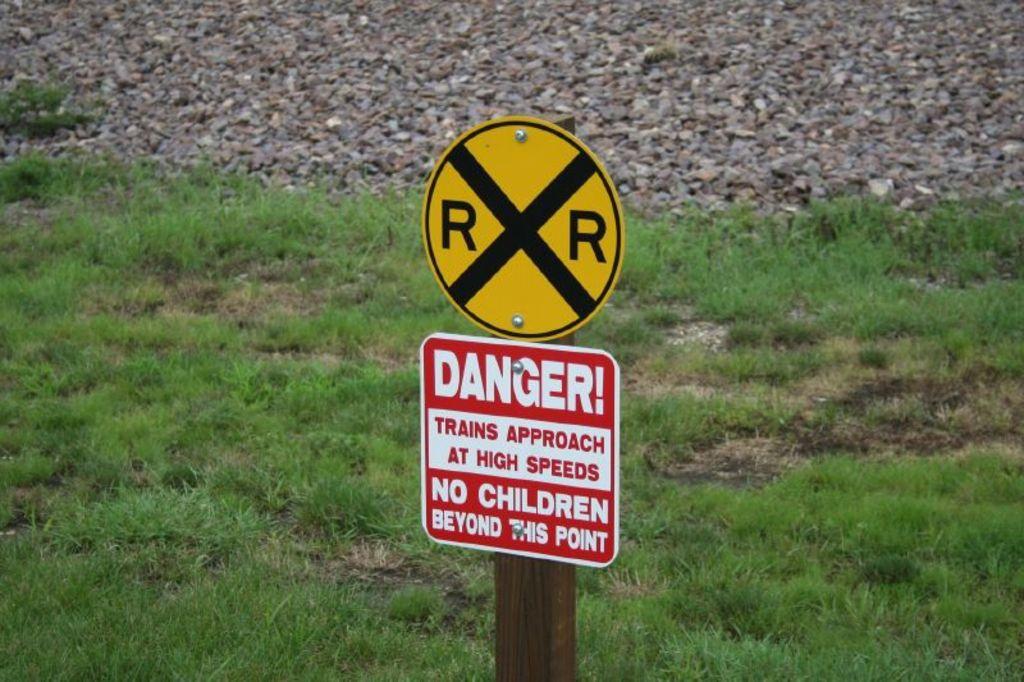What approaches at high speeds?
Offer a terse response. Trains. What is not allowed beyond this point?
Your answer should be very brief. Children. 